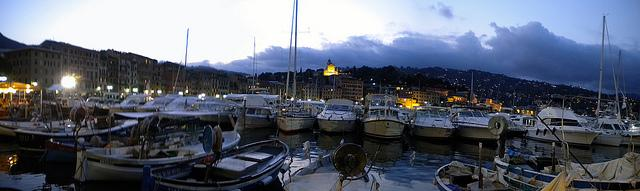What are the round objects on the boats used for?

Choices:
A) hoisting sails
B) going faster
C) stopping suddenly
D) steering boat hoisting sails 